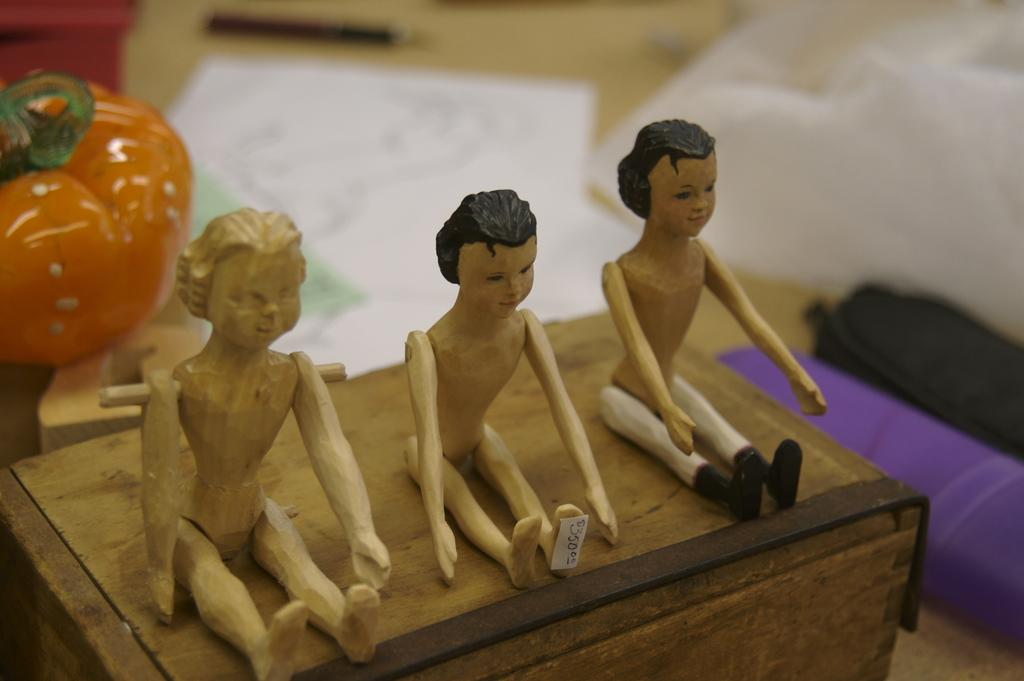What objects are present in the image? There are figurines in the image. Can you describe the background of the image? The background of the image is blurry. What type of wire is being used to connect the figurines in the image? There is no wire present in the image; the figurines are not connected by any visible wires. Where is the nearest hospital in relation to the location of the image? The provided facts do not give any information about the location of the image, so it is impossible to determine the nearest hospital. 